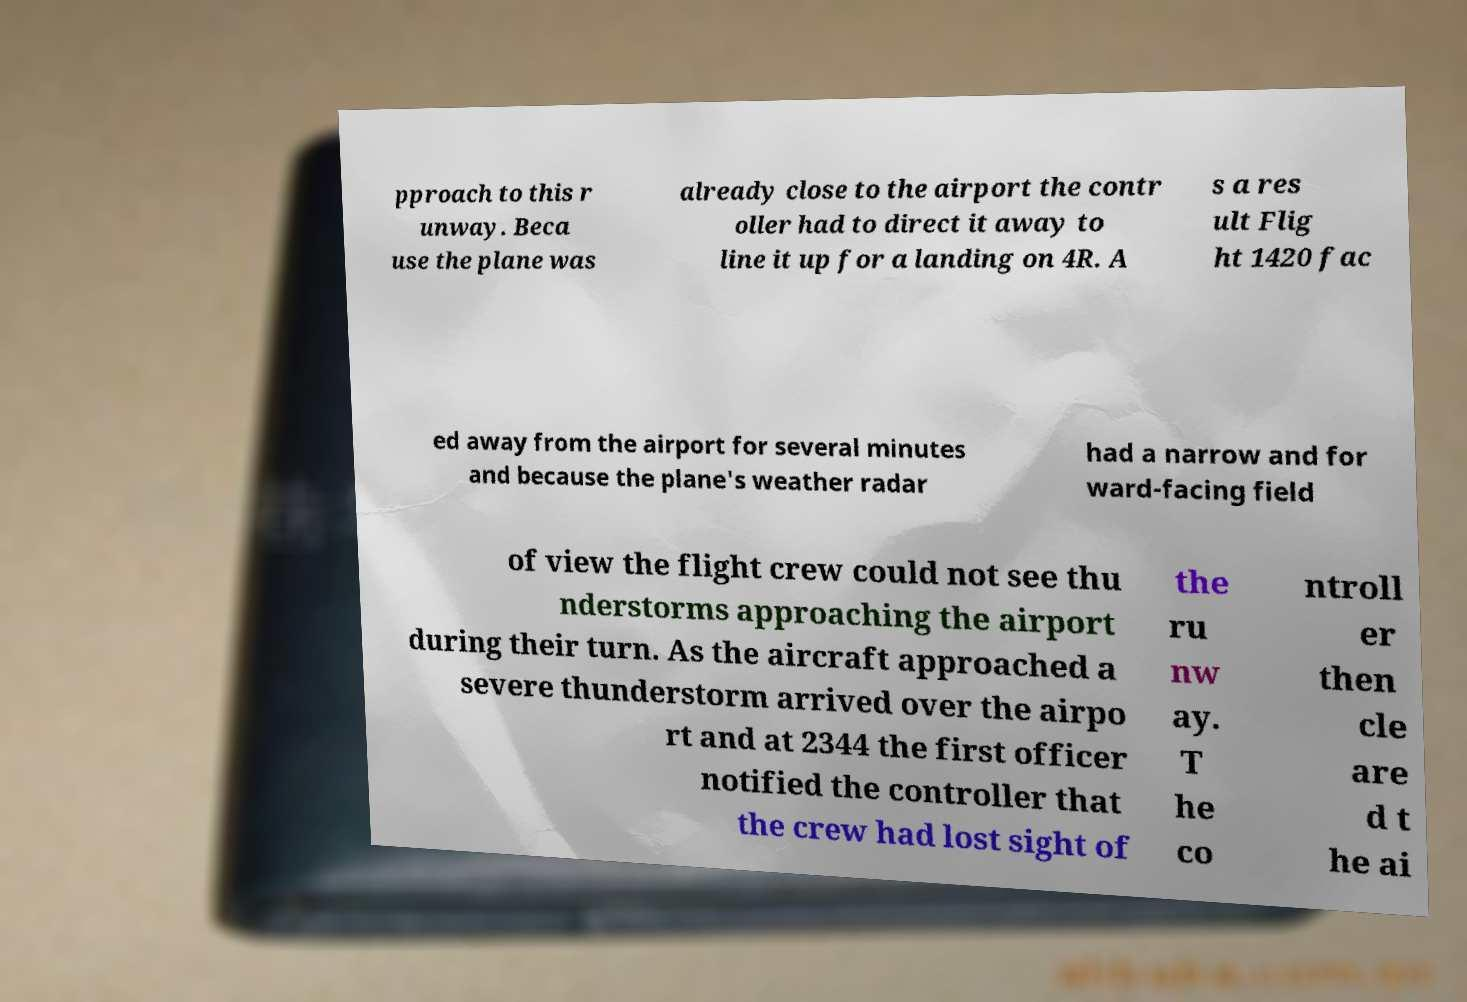What messages or text are displayed in this image? I need them in a readable, typed format. pproach to this r unway. Beca use the plane was already close to the airport the contr oller had to direct it away to line it up for a landing on 4R. A s a res ult Flig ht 1420 fac ed away from the airport for several minutes and because the plane's weather radar had a narrow and for ward-facing field of view the flight crew could not see thu nderstorms approaching the airport during their turn. As the aircraft approached a severe thunderstorm arrived over the airpo rt and at 2344 the first officer notified the controller that the crew had lost sight of the ru nw ay. T he co ntroll er then cle are d t he ai 